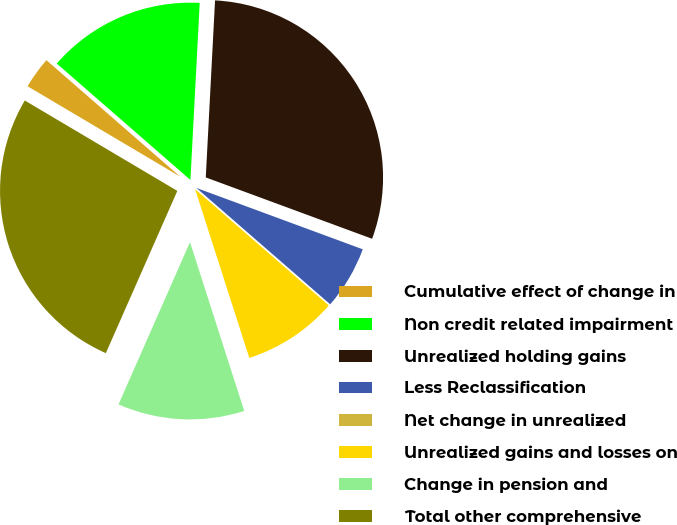Convert chart to OTSL. <chart><loc_0><loc_0><loc_500><loc_500><pie_chart><fcel>Cumulative effect of change in<fcel>Non credit related impairment<fcel>Unrealized holding gains<fcel>Less Reclassification<fcel>Net change in unrealized<fcel>Unrealized gains and losses on<fcel>Change in pension and<fcel>Total other comprehensive<nl><fcel>2.89%<fcel>14.43%<fcel>29.79%<fcel>5.77%<fcel>0.0%<fcel>8.66%<fcel>11.55%<fcel>26.91%<nl></chart> 